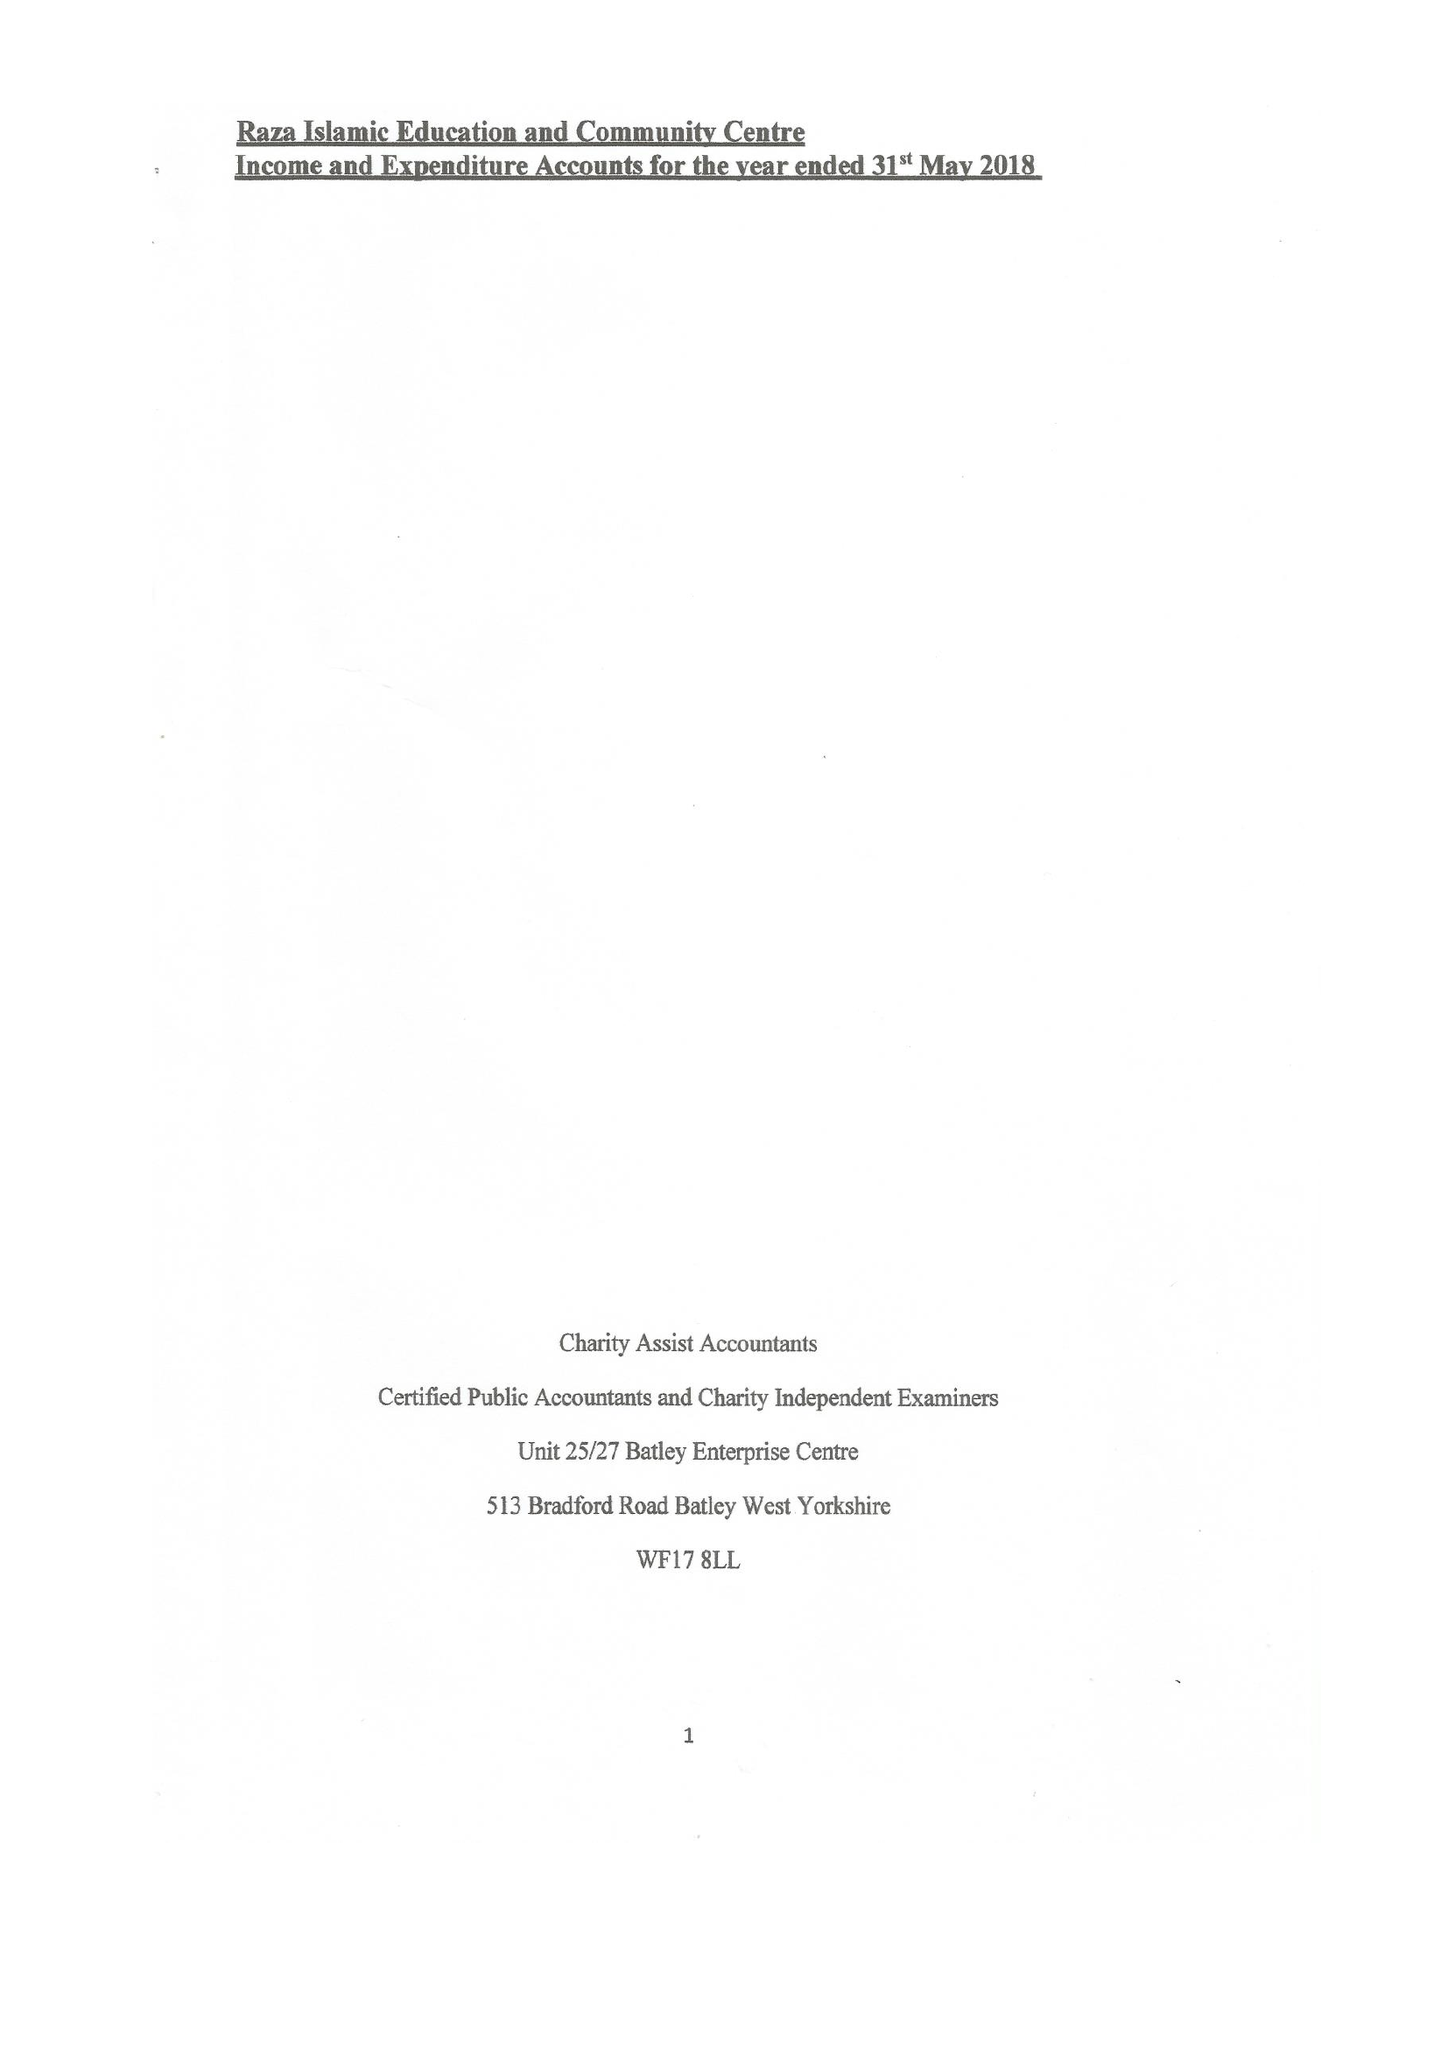What is the value for the address__street_line?
Answer the question using a single word or phrase. 399 LEES HALL ROAD 